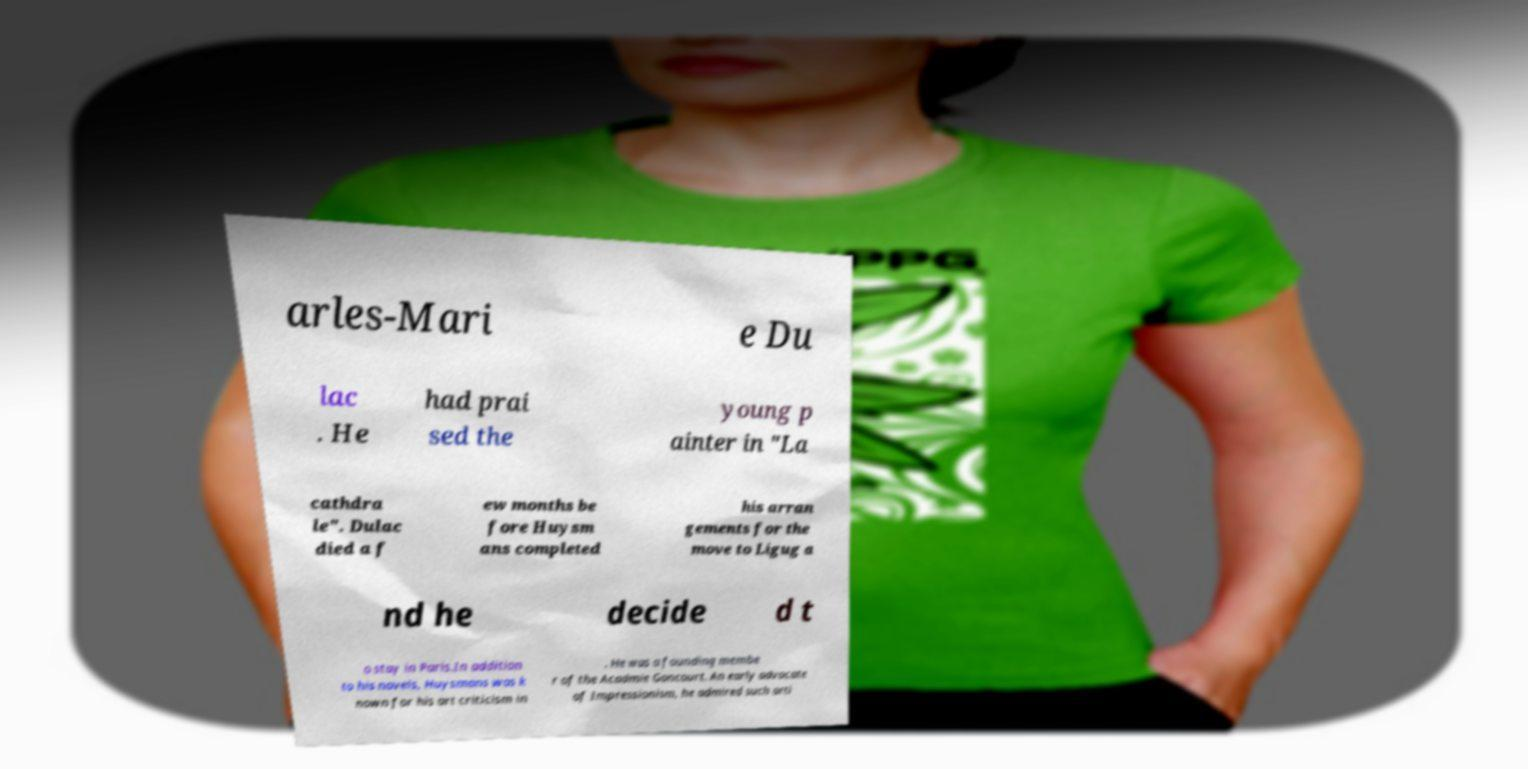Please identify and transcribe the text found in this image. arles-Mari e Du lac . He had prai sed the young p ainter in "La cathdra le". Dulac died a f ew months be fore Huysm ans completed his arran gements for the move to Ligug a nd he decide d t o stay in Paris.In addition to his novels, Huysmans was k nown for his art criticism in . He was a founding membe r of the Acadmie Goncourt. An early advocate of Impressionism, he admired such arti 